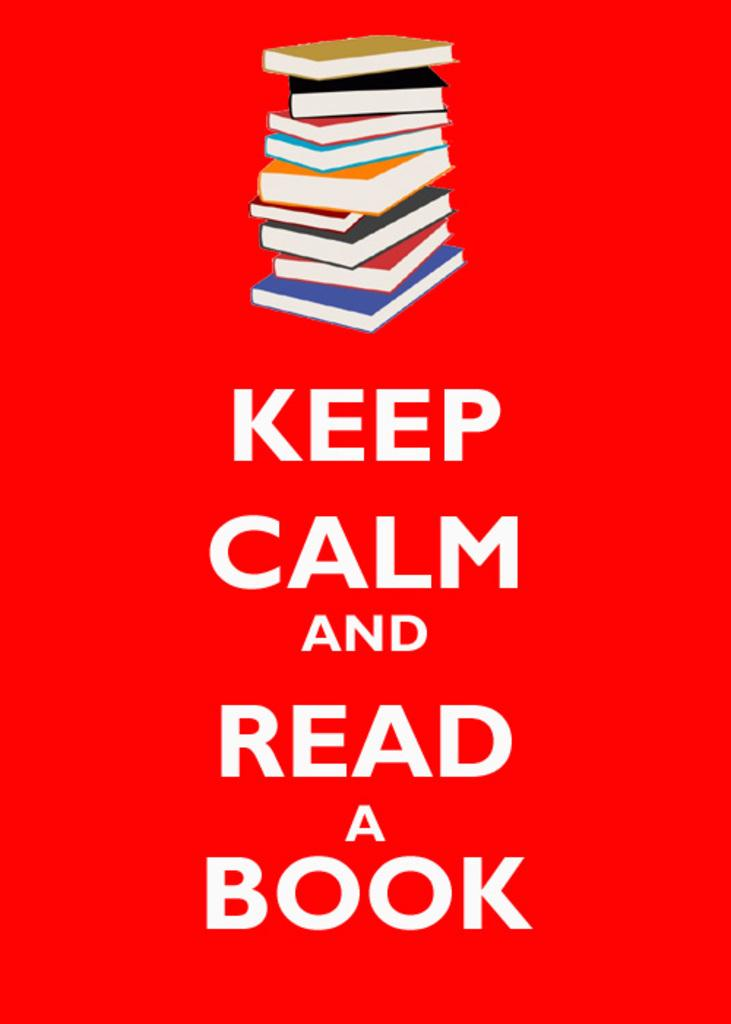<image>
Describe the image concisely. A sign with a stack of books that says Keep Calm and Read a Book 